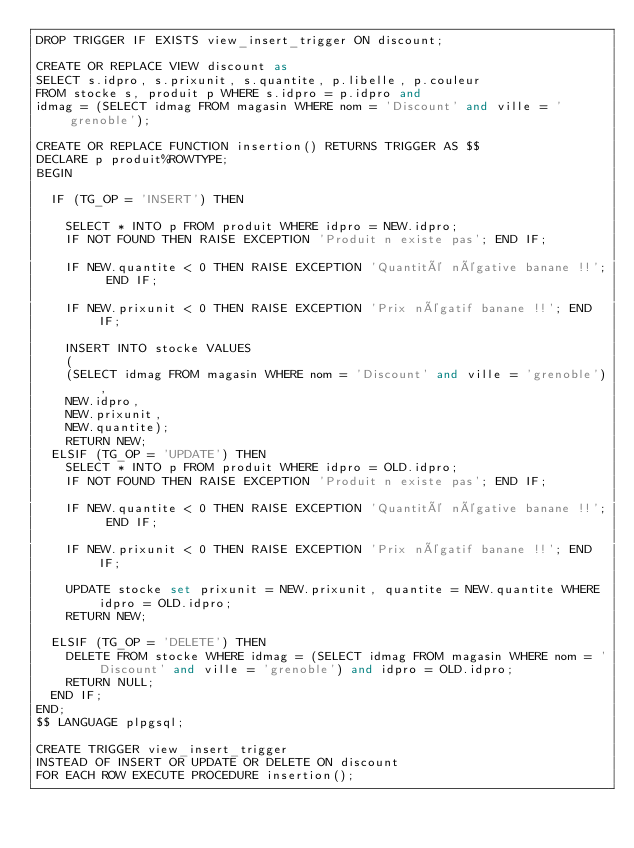<code> <loc_0><loc_0><loc_500><loc_500><_SQL_>DROP TRIGGER IF EXISTS view_insert_trigger ON discount;

CREATE OR REPLACE VIEW discount as
SELECT s.idpro, s.prixunit, s.quantite, p.libelle, p.couleur 
FROM stocke s, produit p WHERE s.idpro = p.idpro and 
idmag = (SELECT idmag FROM magasin WHERE nom = 'Discount' and ville = 'grenoble');

CREATE OR REPLACE FUNCTION insertion() RETURNS TRIGGER AS $$ 
DECLARE p produit%ROWTYPE;
BEGIN 

	IF (TG_OP = 'INSERT') THEN

		SELECT * INTO p FROM produit WHERE idpro = NEW.idpro;
		IF NOT FOUND THEN RAISE EXCEPTION 'Produit n existe pas'; END IF;

		IF NEW.quantite < 0 THEN RAISE EXCEPTION 'Quantité négative banane !!'; END IF;

		IF NEW.prixunit < 0 THEN RAISE EXCEPTION 'Prix négatif banane !!'; END IF;

		INSERT INTO stocke VALUES 
		(
		(SELECT idmag FROM magasin WHERE nom = 'Discount' and ville = 'grenoble'), 
		NEW.idpro, 
		NEW.prixunit, 
		NEW.quantite);
		RETURN NEW;
	ELSIF (TG_OP = 'UPDATE') THEN
		SELECT * INTO p FROM produit WHERE idpro = OLD.idpro;
		IF NOT FOUND THEN RAISE EXCEPTION 'Produit n existe pas'; END IF;

		IF NEW.quantite < 0 THEN RAISE EXCEPTION 'Quantité négative banane !!'; END IF;

		IF NEW.prixunit < 0 THEN RAISE EXCEPTION 'Prix négatif banane !!'; END IF;

		UPDATE stocke set prixunit = NEW.prixunit, quantite = NEW.quantite WHERE idpro = OLD.idpro;
		RETURN NEW;

	ELSIF (TG_OP = 'DELETE') THEN 
		DELETE FROM stocke WHERE idmag = (SELECT idmag FROM magasin WHERE nom = 'Discount' and ville = 'grenoble') and idpro = OLD.idpro;
		RETURN NULL;
	END IF;
END; 
$$ LANGUAGE plpgsql;

CREATE TRIGGER view_insert_trigger
INSTEAD OF INSERT OR UPDATE OR DELETE ON discount 
FOR EACH ROW EXECUTE PROCEDURE insertion();</code> 